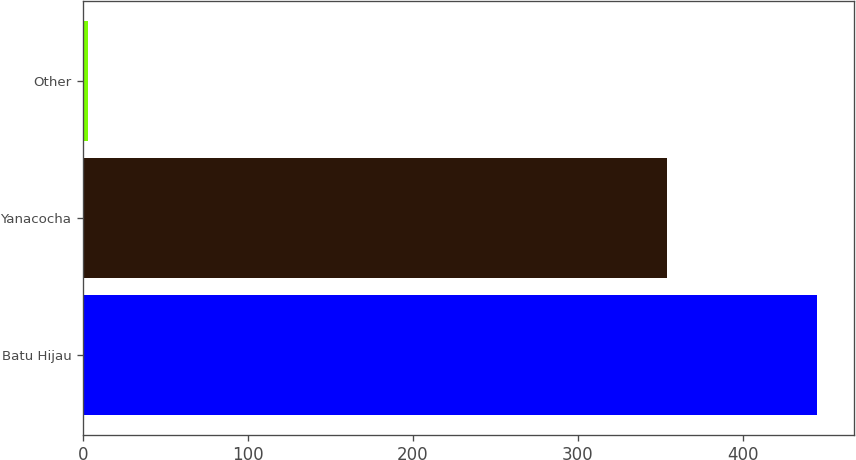Convert chart. <chart><loc_0><loc_0><loc_500><loc_500><bar_chart><fcel>Batu Hijau<fcel>Yanacocha<fcel>Other<nl><fcel>445<fcel>354<fcel>3<nl></chart> 